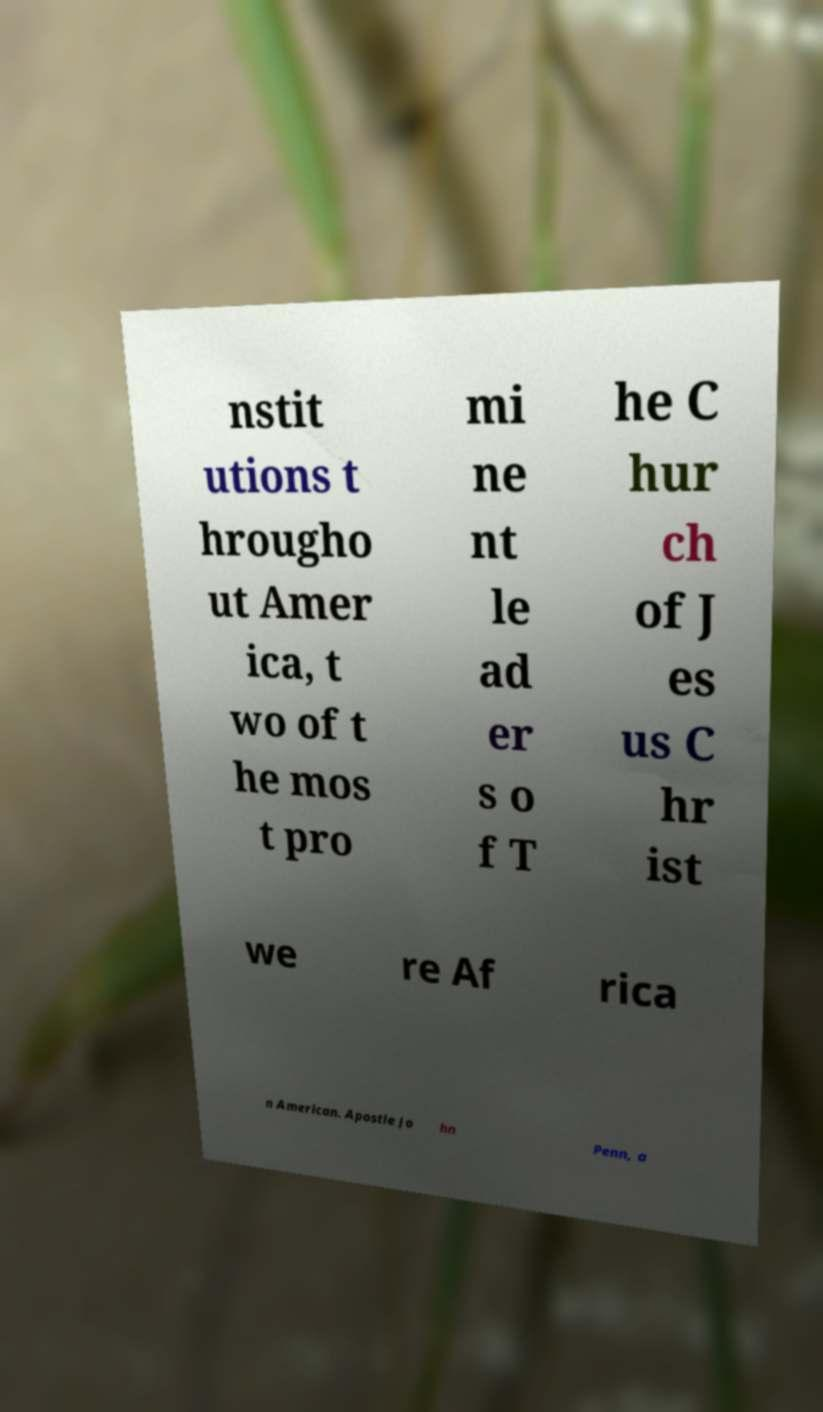Can you accurately transcribe the text from the provided image for me? nstit utions t hrougho ut Amer ica, t wo of t he mos t pro mi ne nt le ad er s o f T he C hur ch of J es us C hr ist we re Af rica n American. Apostle Jo hn Penn, a 